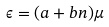<formula> <loc_0><loc_0><loc_500><loc_500>\epsilon = ( a + b n ) \mu</formula> 